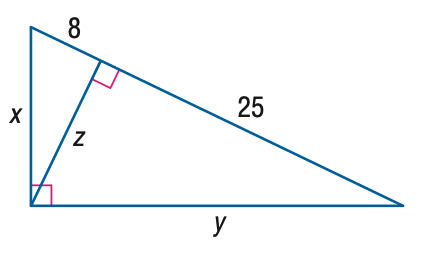Answer the mathemtical geometry problem and directly provide the correct option letter.
Question: Find y.
Choices: A: 10 \sqrt { 2 } B: 5 \sqrt { 17 } C: 25 D: 5 \sqrt { 33 } D 